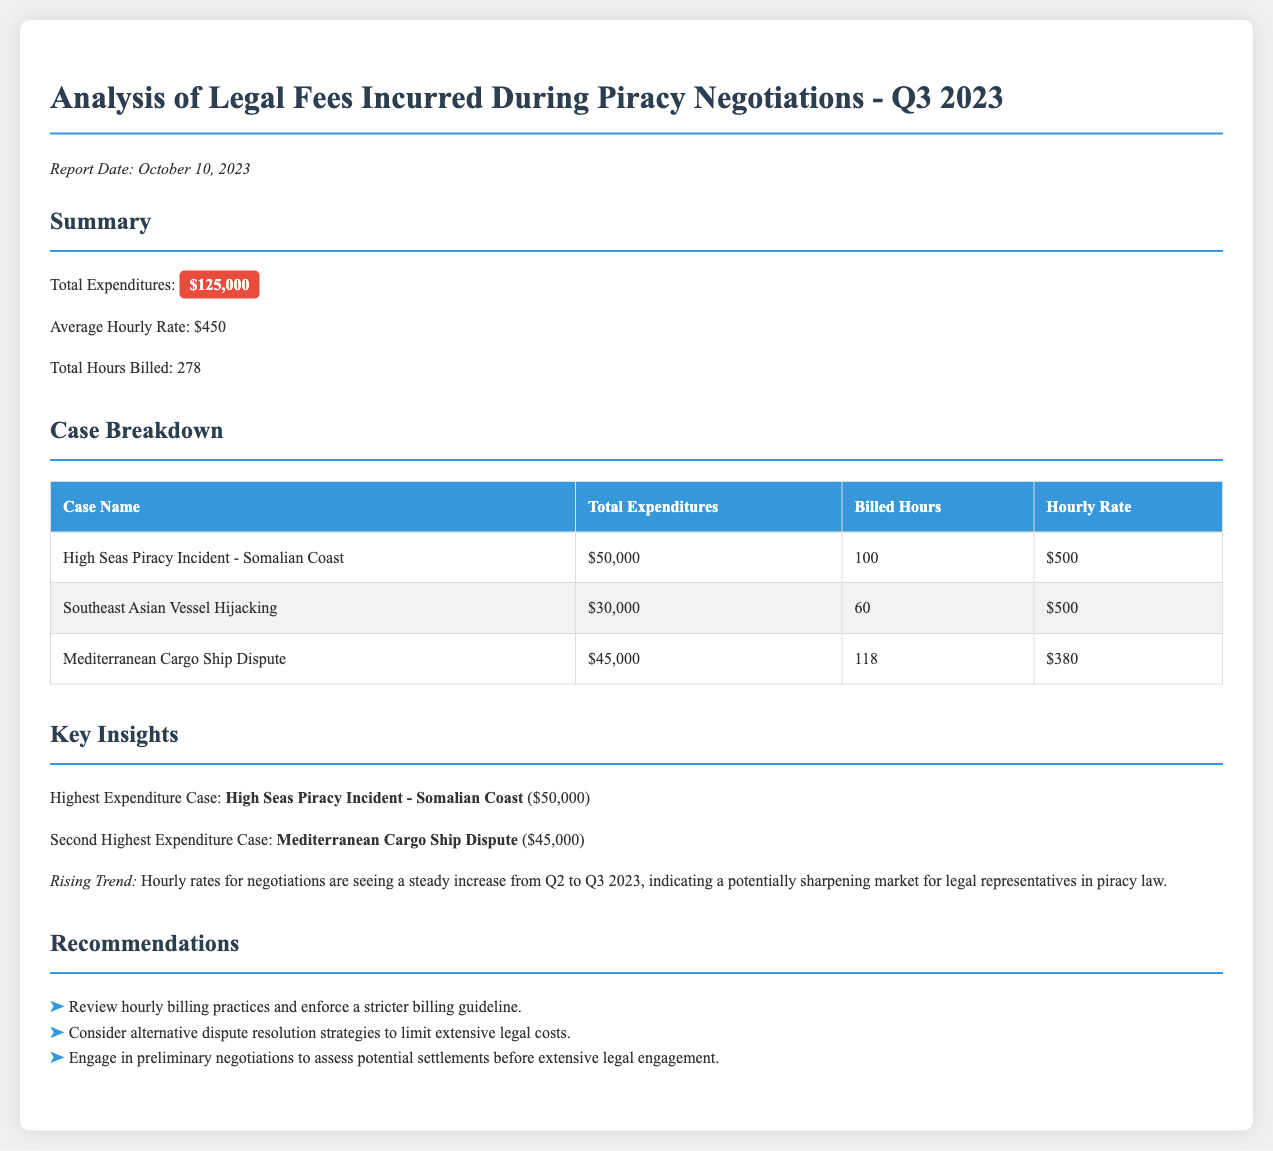What is the total expenditure for Q3 2023? The total expenditure is clearly stated in the summary section of the document.
Answer: $125,000 What is the average hourly rate? The average hourly rate is listed in the summary part, indicating the typical cost per hour for legal services.
Answer: $450 How many total hours were billed? The total billed hours are reported in the summary, which shows the cumulative time spent on legal services.
Answer: 278 Which case had the highest expenditure? The highest expenditure case is highlighted in the insights section, identifying the most costly legal matter handled.
Answer: High Seas Piracy Incident - Somalian Coast What were the billed hours for the Mediterranean Cargo Ship Dispute? The table in the case breakdown provides detailed information about each case, including the hours billed for this specific matter.
Answer: 118 What was the total expenditure for the Southeast Asian Vessel Hijacking case? This information can be found directly in the case breakdown table, which lists financial details for each case individually.
Answer: $30,000 What is the rising trend observed in the report? The key insights section mentions trends regarding costs of legal representation, indicating broader changes in the legal market.
Answer: Hourly rates are increasing How many recommendations are provided in the report? The recommendations section lists actionable items that address the expenditure issues, and the count can be determined from the list.
Answer: 3 What is the total expenditure for the High Seas Piracy Incident? This amount is specified in the case breakdown table, detailing financial implications for that particular case.
Answer: $50,000 